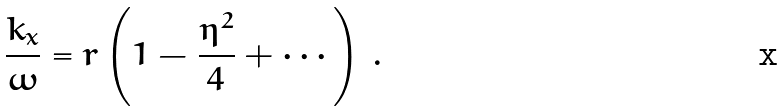Convert formula to latex. <formula><loc_0><loc_0><loc_500><loc_500>\frac { k _ { x } } { \omega } = r \left ( 1 - \frac { \eta ^ { 2 } } { 4 } + \cdots \right ) \, .</formula> 